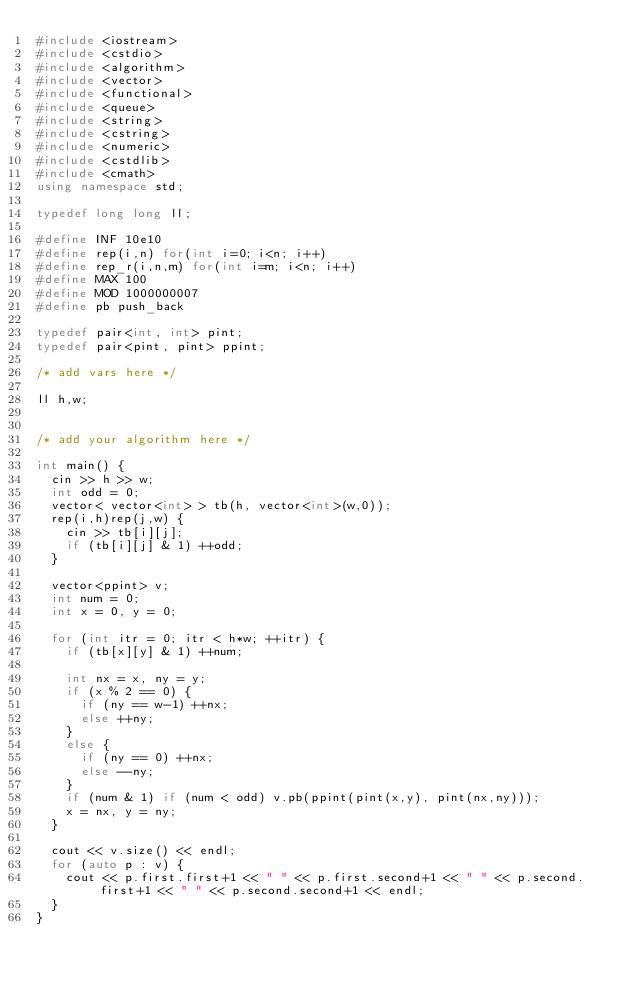<code> <loc_0><loc_0><loc_500><loc_500><_C++_>#include <iostream>
#include <cstdio>
#include <algorithm>
#include <vector>
#include <functional>
#include <queue>
#include <string>
#include <cstring>
#include <numeric>
#include <cstdlib>
#include <cmath>
using namespace std;

typedef long long ll;

#define INF 10e10
#define rep(i,n) for(int i=0; i<n; i++)
#define rep_r(i,n,m) for(int i=m; i<n; i++)
#define MAX 100
#define MOD 1000000007
#define pb push_back

typedef pair<int, int> pint;
typedef pair<pint, pint> ppint;

/* add vars here */

ll h,w;


/* add your algorithm here */

int main() {
  cin >> h >> w;
  int odd = 0;
  vector< vector<int> > tb(h, vector<int>(w,0));
  rep(i,h)rep(j,w) {
    cin >> tb[i][j];
    if (tb[i][j] & 1) ++odd;
  }

  vector<ppint> v;
  int num = 0;
  int x = 0, y = 0;

  for (int itr = 0; itr < h*w; ++itr) {
    if (tb[x][y] & 1) ++num;

    int nx = x, ny = y;
    if (x % 2 == 0) {
      if (ny == w-1) ++nx;
      else ++ny;
    }
    else {
      if (ny == 0) ++nx;
      else --ny;
    }
    if (num & 1) if (num < odd) v.pb(ppint(pint(x,y), pint(nx,ny)));
    x = nx, y = ny;
  }

  cout << v.size() << endl;
  for (auto p : v) {
    cout << p.first.first+1 << " " << p.first.second+1 << " " << p.second.first+1 << " " << p.second.second+1 << endl;
  }
}
</code> 